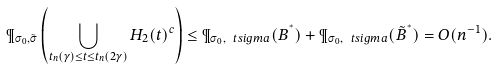<formula> <loc_0><loc_0><loc_500><loc_500>\P _ { \sigma _ { 0 } , \tilde { \sigma } } \left ( \bigcup _ { t _ { n } ( \gamma ) \leq t \leq t _ { n } ( 2 \gamma ) } H _ { 2 } ( t ) ^ { c } \right ) \leq \P _ { \sigma _ { 0 } , \ t s i g m a } ( B ^ { ^ { * } } ) + \P _ { \sigma _ { 0 } , \ t s i g m a } ( \tilde { B } ^ { ^ { * } } ) = O ( n ^ { - 1 } ) .</formula> 